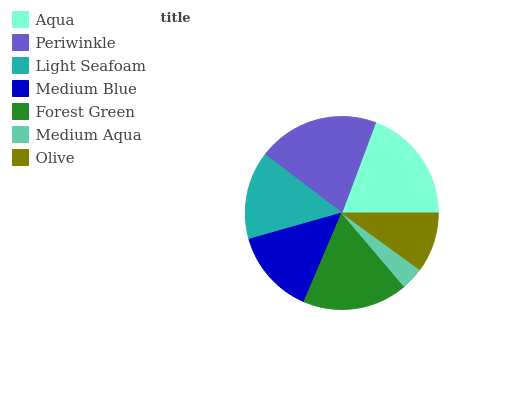Is Medium Aqua the minimum?
Answer yes or no. Yes. Is Periwinkle the maximum?
Answer yes or no. Yes. Is Light Seafoam the minimum?
Answer yes or no. No. Is Light Seafoam the maximum?
Answer yes or no. No. Is Periwinkle greater than Light Seafoam?
Answer yes or no. Yes. Is Light Seafoam less than Periwinkle?
Answer yes or no. Yes. Is Light Seafoam greater than Periwinkle?
Answer yes or no. No. Is Periwinkle less than Light Seafoam?
Answer yes or no. No. Is Light Seafoam the high median?
Answer yes or no. Yes. Is Light Seafoam the low median?
Answer yes or no. Yes. Is Medium Aqua the high median?
Answer yes or no. No. Is Medium Aqua the low median?
Answer yes or no. No. 